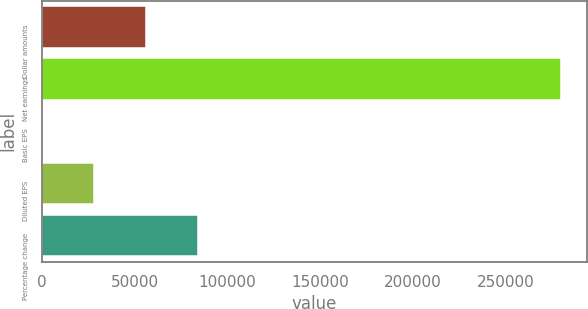Convert chart. <chart><loc_0><loc_0><loc_500><loc_500><bar_chart><fcel>Dollar amounts<fcel>Net earnings<fcel>Basic EPS<fcel>Diluted EPS<fcel>Percentage change<nl><fcel>55942.5<fcel>279705<fcel>1.88<fcel>27972.2<fcel>83912.8<nl></chart> 